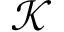Convert formula to latex. <formula><loc_0><loc_0><loc_500><loc_500>\mathcal { K }</formula> 